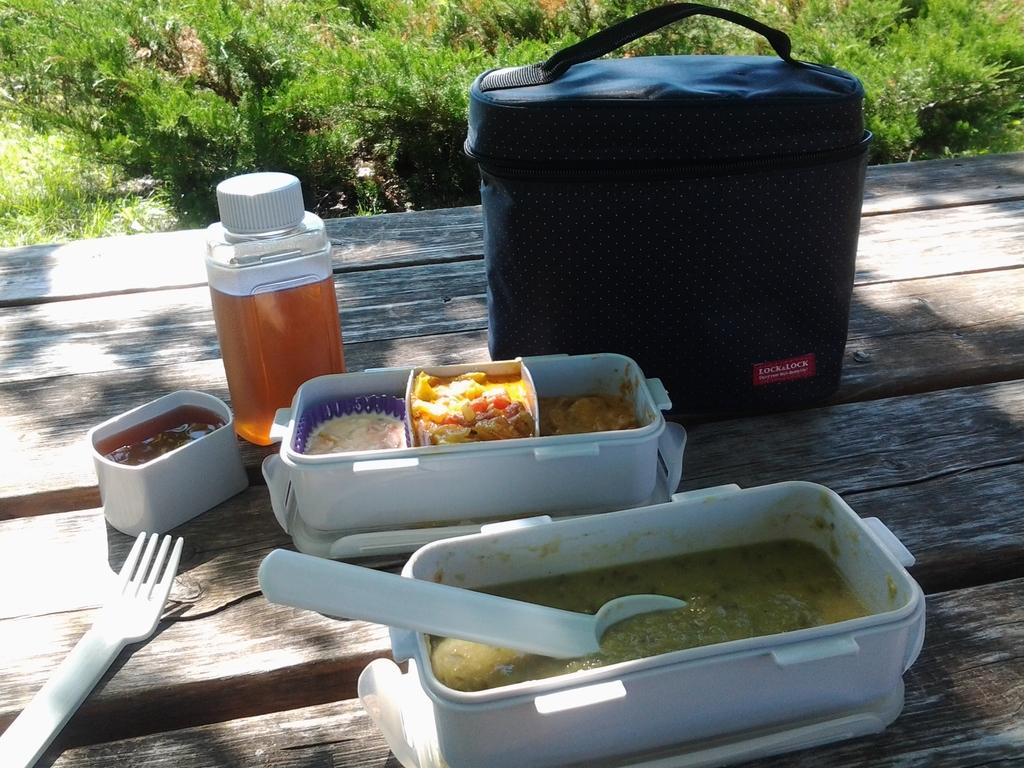What is the brand of the lunch bag?
Keep it short and to the point. Lock & lock. 